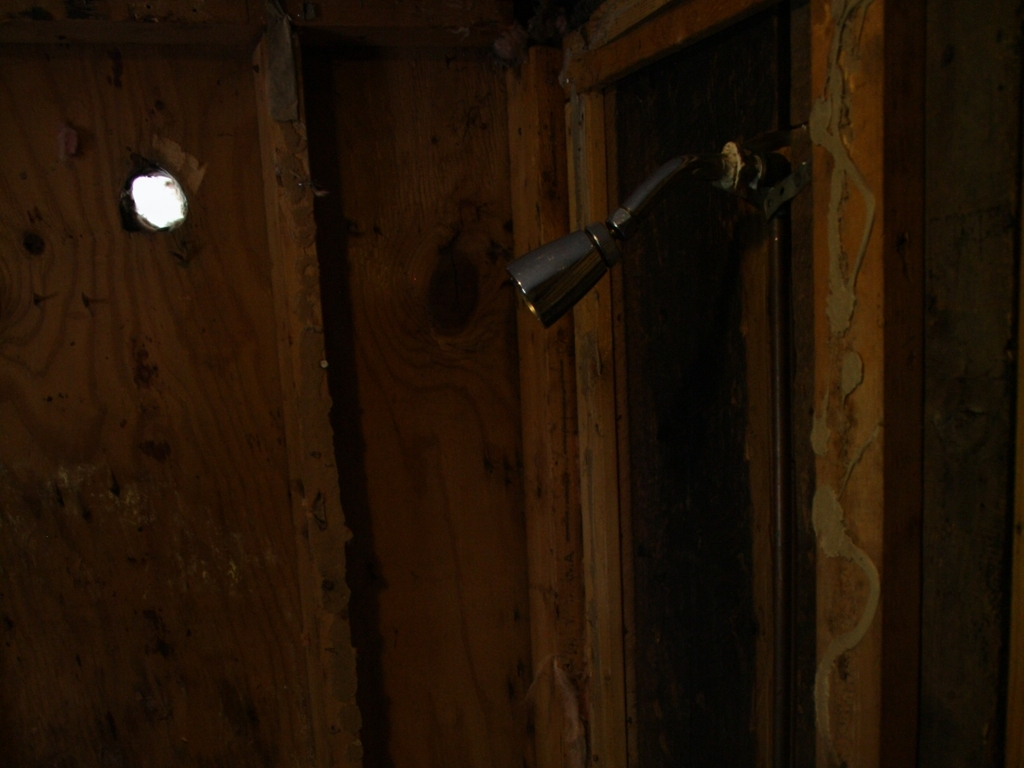What is the visible content in the image? The image shows a dimly lit interior space with wooden surfaces. There is a faucet protruding from the wall on the right, possibly indicating a removed sink or fixture. On the left wall, there's a small, circular hole allowing some light to enter the space. The walls appear worn and in a state of disrepair, with exposed insulation and gaps between the wooden panels. 